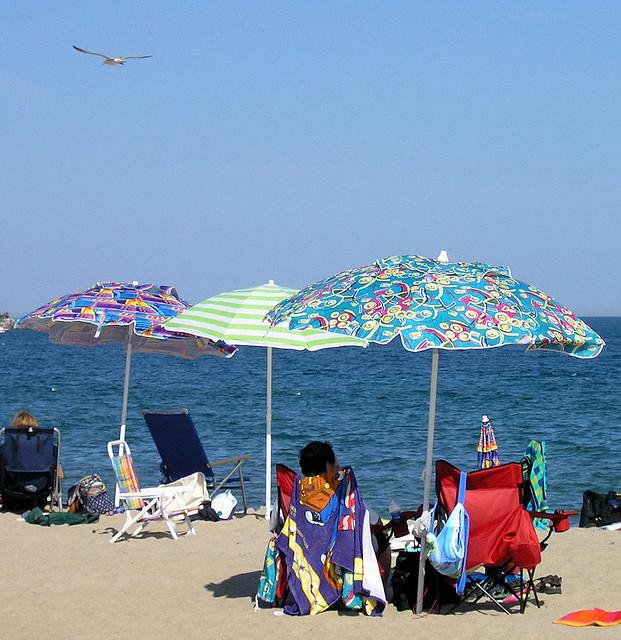What other situation might the standing items be useful for? rain 